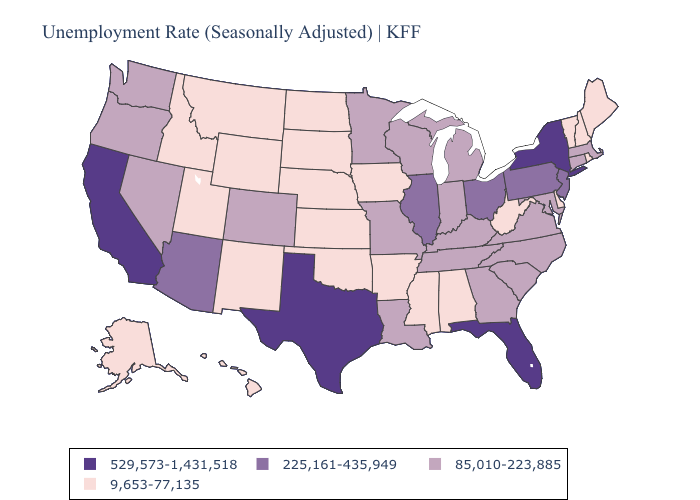Does South Dakota have the highest value in the USA?
Give a very brief answer. No. Name the states that have a value in the range 225,161-435,949?
Keep it brief. Arizona, Illinois, New Jersey, Ohio, Pennsylvania. Which states hav the highest value in the South?
Answer briefly. Florida, Texas. What is the lowest value in states that border Rhode Island?
Keep it brief. 85,010-223,885. Which states have the lowest value in the West?
Answer briefly. Alaska, Hawaii, Idaho, Montana, New Mexico, Utah, Wyoming. Does Virginia have a lower value than Connecticut?
Quick response, please. No. Name the states that have a value in the range 225,161-435,949?
Concise answer only. Arizona, Illinois, New Jersey, Ohio, Pennsylvania. What is the lowest value in states that border Texas?
Concise answer only. 9,653-77,135. Name the states that have a value in the range 9,653-77,135?
Short answer required. Alabama, Alaska, Arkansas, Delaware, Hawaii, Idaho, Iowa, Kansas, Maine, Mississippi, Montana, Nebraska, New Hampshire, New Mexico, North Dakota, Oklahoma, Rhode Island, South Dakota, Utah, Vermont, West Virginia, Wyoming. What is the lowest value in the South?
Quick response, please. 9,653-77,135. What is the value of Alabama?
Give a very brief answer. 9,653-77,135. Among the states that border Michigan , does Indiana have the highest value?
Be succinct. No. Does Utah have the highest value in the USA?
Be succinct. No. What is the value of South Carolina?
Short answer required. 85,010-223,885. Does Michigan have a higher value than Minnesota?
Be succinct. No. 